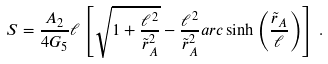Convert formula to latex. <formula><loc_0><loc_0><loc_500><loc_500>S = \frac { A _ { 2 } } { 4 G _ { 5 } } \ell \left [ \sqrt { 1 + \frac { \ell ^ { 2 } } { \tilde { r } _ { A } ^ { 2 } } } - \frac { \ell ^ { 2 } } { \tilde { r } _ { A } ^ { 2 } } a r c \sinh \left ( \frac { \tilde { r } _ { A } } { \ell } \right ) \right ] \, .</formula> 